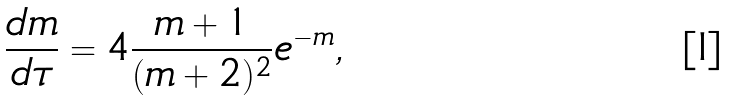<formula> <loc_0><loc_0><loc_500><loc_500>\frac { d m } { d \tau } = 4 \frac { m + 1 } { ( m + 2 ) ^ { 2 } } e ^ { - m } ,</formula> 